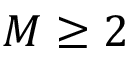<formula> <loc_0><loc_0><loc_500><loc_500>M \geq 2</formula> 